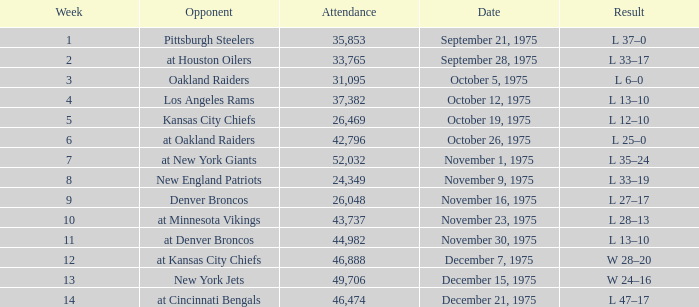What is the average Week when the result was w 28–20, and there were more than 46,888 in attendance? None. 